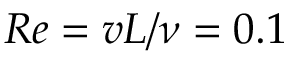<formula> <loc_0><loc_0><loc_500><loc_500>R e = v L / \nu = 0 . 1</formula> 